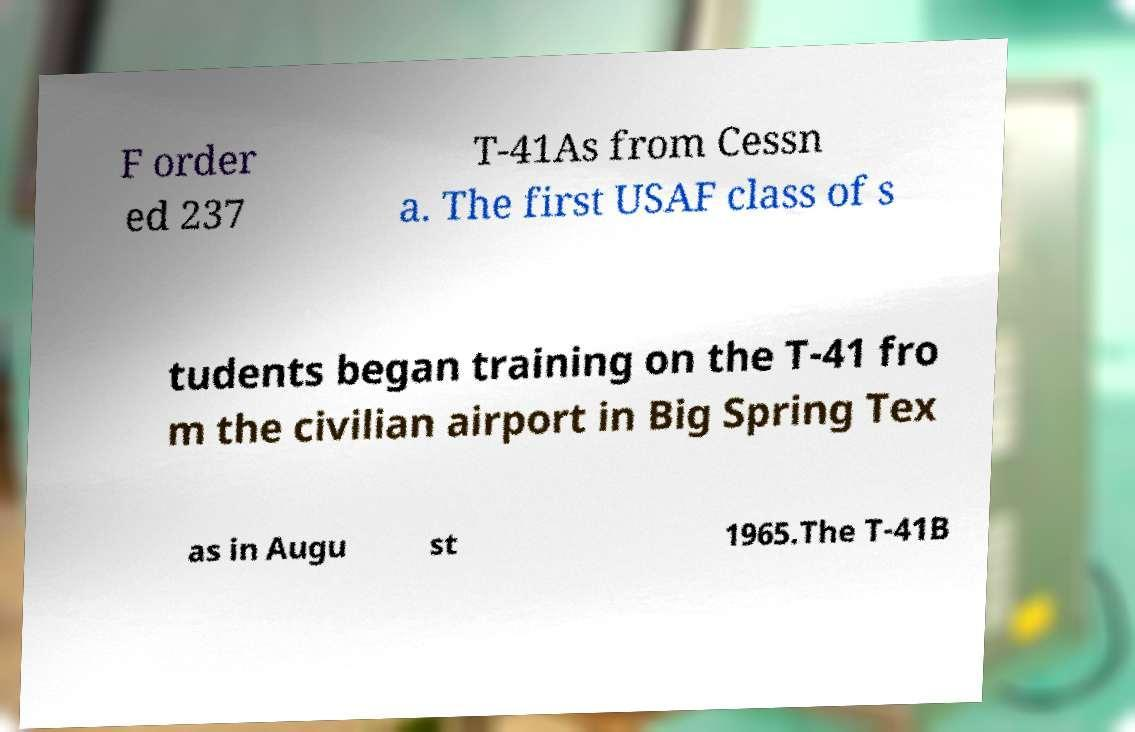Please identify and transcribe the text found in this image. F order ed 237 T-41As from Cessn a. The first USAF class of s tudents began training on the T-41 fro m the civilian airport in Big Spring Tex as in Augu st 1965.The T-41B 